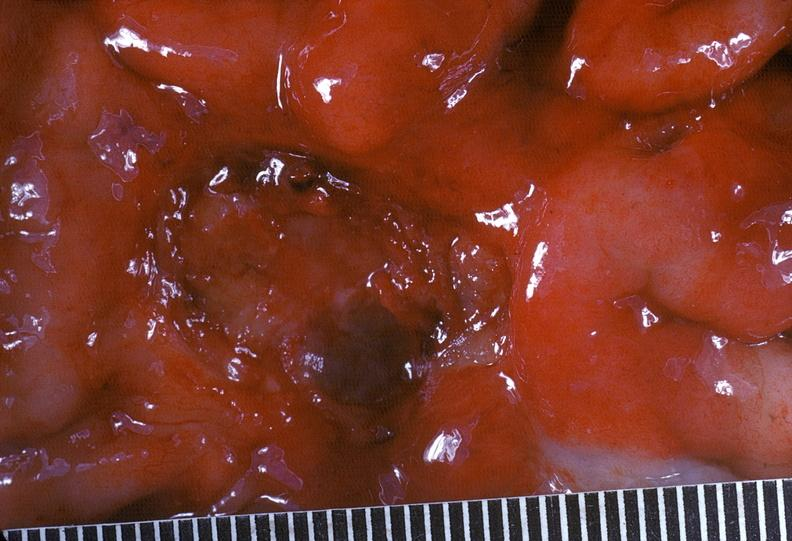does intraductal papillomatosis show stomach, peptic ulcer, chronic and peripheral carcinoma?
Answer the question using a single word or phrase. No 